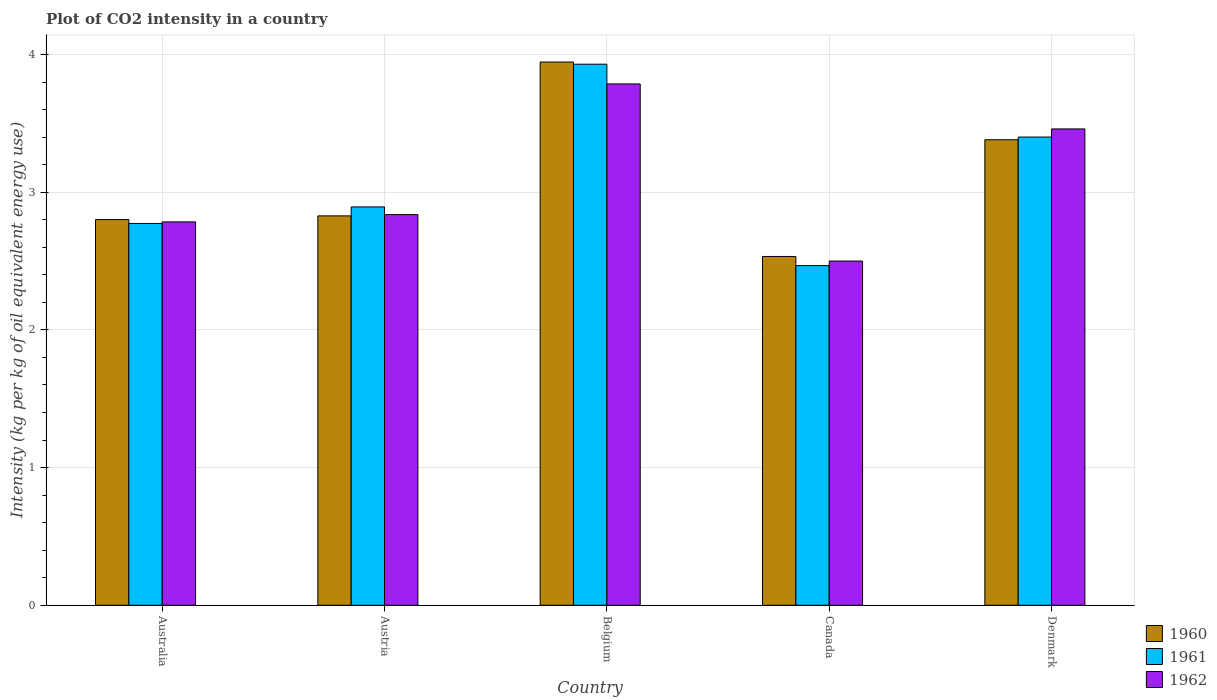Are the number of bars per tick equal to the number of legend labels?
Provide a succinct answer. Yes. Are the number of bars on each tick of the X-axis equal?
Offer a terse response. Yes. How many bars are there on the 2nd tick from the left?
Give a very brief answer. 3. What is the label of the 5th group of bars from the left?
Your answer should be very brief. Denmark. In how many cases, is the number of bars for a given country not equal to the number of legend labels?
Your response must be concise. 0. What is the CO2 intensity in in 1961 in Canada?
Make the answer very short. 2.47. Across all countries, what is the maximum CO2 intensity in in 1962?
Offer a terse response. 3.79. Across all countries, what is the minimum CO2 intensity in in 1960?
Provide a short and direct response. 2.53. In which country was the CO2 intensity in in 1960 minimum?
Your answer should be very brief. Canada. What is the total CO2 intensity in in 1961 in the graph?
Give a very brief answer. 15.47. What is the difference between the CO2 intensity in in 1960 in Austria and that in Canada?
Keep it short and to the point. 0.29. What is the difference between the CO2 intensity in in 1962 in Australia and the CO2 intensity in in 1960 in Belgium?
Offer a very short reply. -1.16. What is the average CO2 intensity in in 1962 per country?
Provide a succinct answer. 3.07. What is the difference between the CO2 intensity in of/in 1962 and CO2 intensity in of/in 1960 in Australia?
Your answer should be compact. -0.02. What is the ratio of the CO2 intensity in in 1960 in Belgium to that in Canada?
Your answer should be very brief. 1.56. Is the CO2 intensity in in 1961 in Canada less than that in Denmark?
Ensure brevity in your answer.  Yes. Is the difference between the CO2 intensity in in 1962 in Australia and Denmark greater than the difference between the CO2 intensity in in 1960 in Australia and Denmark?
Your answer should be compact. No. What is the difference between the highest and the second highest CO2 intensity in in 1961?
Your response must be concise. 0.51. What is the difference between the highest and the lowest CO2 intensity in in 1961?
Provide a short and direct response. 1.46. Is the sum of the CO2 intensity in in 1962 in Australia and Denmark greater than the maximum CO2 intensity in in 1961 across all countries?
Your answer should be compact. Yes. Are all the bars in the graph horizontal?
Provide a succinct answer. No. What is the difference between two consecutive major ticks on the Y-axis?
Keep it short and to the point. 1. Are the values on the major ticks of Y-axis written in scientific E-notation?
Your answer should be compact. No. Does the graph contain grids?
Make the answer very short. Yes. How are the legend labels stacked?
Keep it short and to the point. Vertical. What is the title of the graph?
Give a very brief answer. Plot of CO2 intensity in a country. Does "1996" appear as one of the legend labels in the graph?
Make the answer very short. No. What is the label or title of the X-axis?
Ensure brevity in your answer.  Country. What is the label or title of the Y-axis?
Ensure brevity in your answer.  Intensity (kg per kg of oil equivalent energy use). What is the Intensity (kg per kg of oil equivalent energy use) in 1960 in Australia?
Provide a succinct answer. 2.8. What is the Intensity (kg per kg of oil equivalent energy use) in 1961 in Australia?
Provide a succinct answer. 2.77. What is the Intensity (kg per kg of oil equivalent energy use) in 1962 in Australia?
Provide a succinct answer. 2.78. What is the Intensity (kg per kg of oil equivalent energy use) in 1960 in Austria?
Your answer should be compact. 2.83. What is the Intensity (kg per kg of oil equivalent energy use) in 1961 in Austria?
Provide a succinct answer. 2.89. What is the Intensity (kg per kg of oil equivalent energy use) in 1962 in Austria?
Make the answer very short. 2.84. What is the Intensity (kg per kg of oil equivalent energy use) in 1960 in Belgium?
Your answer should be compact. 3.95. What is the Intensity (kg per kg of oil equivalent energy use) in 1961 in Belgium?
Give a very brief answer. 3.93. What is the Intensity (kg per kg of oil equivalent energy use) of 1962 in Belgium?
Make the answer very short. 3.79. What is the Intensity (kg per kg of oil equivalent energy use) of 1960 in Canada?
Ensure brevity in your answer.  2.53. What is the Intensity (kg per kg of oil equivalent energy use) in 1961 in Canada?
Your answer should be very brief. 2.47. What is the Intensity (kg per kg of oil equivalent energy use) in 1962 in Canada?
Ensure brevity in your answer.  2.5. What is the Intensity (kg per kg of oil equivalent energy use) of 1960 in Denmark?
Your answer should be compact. 3.38. What is the Intensity (kg per kg of oil equivalent energy use) in 1961 in Denmark?
Keep it short and to the point. 3.4. What is the Intensity (kg per kg of oil equivalent energy use) of 1962 in Denmark?
Provide a succinct answer. 3.46. Across all countries, what is the maximum Intensity (kg per kg of oil equivalent energy use) of 1960?
Offer a terse response. 3.95. Across all countries, what is the maximum Intensity (kg per kg of oil equivalent energy use) in 1961?
Keep it short and to the point. 3.93. Across all countries, what is the maximum Intensity (kg per kg of oil equivalent energy use) of 1962?
Offer a very short reply. 3.79. Across all countries, what is the minimum Intensity (kg per kg of oil equivalent energy use) in 1960?
Make the answer very short. 2.53. Across all countries, what is the minimum Intensity (kg per kg of oil equivalent energy use) in 1961?
Your response must be concise. 2.47. Across all countries, what is the minimum Intensity (kg per kg of oil equivalent energy use) of 1962?
Make the answer very short. 2.5. What is the total Intensity (kg per kg of oil equivalent energy use) in 1960 in the graph?
Ensure brevity in your answer.  15.49. What is the total Intensity (kg per kg of oil equivalent energy use) in 1961 in the graph?
Keep it short and to the point. 15.47. What is the total Intensity (kg per kg of oil equivalent energy use) in 1962 in the graph?
Keep it short and to the point. 15.37. What is the difference between the Intensity (kg per kg of oil equivalent energy use) of 1960 in Australia and that in Austria?
Give a very brief answer. -0.03. What is the difference between the Intensity (kg per kg of oil equivalent energy use) of 1961 in Australia and that in Austria?
Keep it short and to the point. -0.12. What is the difference between the Intensity (kg per kg of oil equivalent energy use) in 1962 in Australia and that in Austria?
Give a very brief answer. -0.05. What is the difference between the Intensity (kg per kg of oil equivalent energy use) in 1960 in Australia and that in Belgium?
Provide a short and direct response. -1.14. What is the difference between the Intensity (kg per kg of oil equivalent energy use) in 1961 in Australia and that in Belgium?
Offer a terse response. -1.16. What is the difference between the Intensity (kg per kg of oil equivalent energy use) of 1962 in Australia and that in Belgium?
Your response must be concise. -1. What is the difference between the Intensity (kg per kg of oil equivalent energy use) of 1960 in Australia and that in Canada?
Offer a very short reply. 0.27. What is the difference between the Intensity (kg per kg of oil equivalent energy use) of 1961 in Australia and that in Canada?
Your answer should be very brief. 0.31. What is the difference between the Intensity (kg per kg of oil equivalent energy use) in 1962 in Australia and that in Canada?
Give a very brief answer. 0.28. What is the difference between the Intensity (kg per kg of oil equivalent energy use) of 1960 in Australia and that in Denmark?
Keep it short and to the point. -0.58. What is the difference between the Intensity (kg per kg of oil equivalent energy use) of 1961 in Australia and that in Denmark?
Provide a succinct answer. -0.63. What is the difference between the Intensity (kg per kg of oil equivalent energy use) of 1962 in Australia and that in Denmark?
Your answer should be very brief. -0.68. What is the difference between the Intensity (kg per kg of oil equivalent energy use) in 1960 in Austria and that in Belgium?
Give a very brief answer. -1.12. What is the difference between the Intensity (kg per kg of oil equivalent energy use) in 1961 in Austria and that in Belgium?
Provide a succinct answer. -1.04. What is the difference between the Intensity (kg per kg of oil equivalent energy use) in 1962 in Austria and that in Belgium?
Your answer should be very brief. -0.95. What is the difference between the Intensity (kg per kg of oil equivalent energy use) in 1960 in Austria and that in Canada?
Ensure brevity in your answer.  0.29. What is the difference between the Intensity (kg per kg of oil equivalent energy use) in 1961 in Austria and that in Canada?
Your answer should be very brief. 0.43. What is the difference between the Intensity (kg per kg of oil equivalent energy use) of 1962 in Austria and that in Canada?
Your answer should be very brief. 0.34. What is the difference between the Intensity (kg per kg of oil equivalent energy use) of 1960 in Austria and that in Denmark?
Ensure brevity in your answer.  -0.55. What is the difference between the Intensity (kg per kg of oil equivalent energy use) in 1961 in Austria and that in Denmark?
Give a very brief answer. -0.51. What is the difference between the Intensity (kg per kg of oil equivalent energy use) of 1962 in Austria and that in Denmark?
Your response must be concise. -0.62. What is the difference between the Intensity (kg per kg of oil equivalent energy use) of 1960 in Belgium and that in Canada?
Make the answer very short. 1.41. What is the difference between the Intensity (kg per kg of oil equivalent energy use) of 1961 in Belgium and that in Canada?
Give a very brief answer. 1.46. What is the difference between the Intensity (kg per kg of oil equivalent energy use) of 1962 in Belgium and that in Canada?
Your answer should be compact. 1.29. What is the difference between the Intensity (kg per kg of oil equivalent energy use) of 1960 in Belgium and that in Denmark?
Your response must be concise. 0.56. What is the difference between the Intensity (kg per kg of oil equivalent energy use) of 1961 in Belgium and that in Denmark?
Ensure brevity in your answer.  0.53. What is the difference between the Intensity (kg per kg of oil equivalent energy use) of 1962 in Belgium and that in Denmark?
Your answer should be very brief. 0.33. What is the difference between the Intensity (kg per kg of oil equivalent energy use) of 1960 in Canada and that in Denmark?
Offer a very short reply. -0.85. What is the difference between the Intensity (kg per kg of oil equivalent energy use) in 1961 in Canada and that in Denmark?
Make the answer very short. -0.93. What is the difference between the Intensity (kg per kg of oil equivalent energy use) of 1962 in Canada and that in Denmark?
Ensure brevity in your answer.  -0.96. What is the difference between the Intensity (kg per kg of oil equivalent energy use) in 1960 in Australia and the Intensity (kg per kg of oil equivalent energy use) in 1961 in Austria?
Make the answer very short. -0.09. What is the difference between the Intensity (kg per kg of oil equivalent energy use) of 1960 in Australia and the Intensity (kg per kg of oil equivalent energy use) of 1962 in Austria?
Ensure brevity in your answer.  -0.04. What is the difference between the Intensity (kg per kg of oil equivalent energy use) in 1961 in Australia and the Intensity (kg per kg of oil equivalent energy use) in 1962 in Austria?
Ensure brevity in your answer.  -0.06. What is the difference between the Intensity (kg per kg of oil equivalent energy use) of 1960 in Australia and the Intensity (kg per kg of oil equivalent energy use) of 1961 in Belgium?
Provide a succinct answer. -1.13. What is the difference between the Intensity (kg per kg of oil equivalent energy use) of 1960 in Australia and the Intensity (kg per kg of oil equivalent energy use) of 1962 in Belgium?
Provide a short and direct response. -0.99. What is the difference between the Intensity (kg per kg of oil equivalent energy use) of 1961 in Australia and the Intensity (kg per kg of oil equivalent energy use) of 1962 in Belgium?
Provide a short and direct response. -1.01. What is the difference between the Intensity (kg per kg of oil equivalent energy use) of 1960 in Australia and the Intensity (kg per kg of oil equivalent energy use) of 1961 in Canada?
Ensure brevity in your answer.  0.33. What is the difference between the Intensity (kg per kg of oil equivalent energy use) of 1960 in Australia and the Intensity (kg per kg of oil equivalent energy use) of 1962 in Canada?
Your answer should be very brief. 0.3. What is the difference between the Intensity (kg per kg of oil equivalent energy use) in 1961 in Australia and the Intensity (kg per kg of oil equivalent energy use) in 1962 in Canada?
Give a very brief answer. 0.27. What is the difference between the Intensity (kg per kg of oil equivalent energy use) of 1960 in Australia and the Intensity (kg per kg of oil equivalent energy use) of 1961 in Denmark?
Your answer should be very brief. -0.6. What is the difference between the Intensity (kg per kg of oil equivalent energy use) in 1960 in Australia and the Intensity (kg per kg of oil equivalent energy use) in 1962 in Denmark?
Make the answer very short. -0.66. What is the difference between the Intensity (kg per kg of oil equivalent energy use) in 1961 in Australia and the Intensity (kg per kg of oil equivalent energy use) in 1962 in Denmark?
Ensure brevity in your answer.  -0.69. What is the difference between the Intensity (kg per kg of oil equivalent energy use) of 1960 in Austria and the Intensity (kg per kg of oil equivalent energy use) of 1961 in Belgium?
Provide a short and direct response. -1.1. What is the difference between the Intensity (kg per kg of oil equivalent energy use) in 1960 in Austria and the Intensity (kg per kg of oil equivalent energy use) in 1962 in Belgium?
Your answer should be very brief. -0.96. What is the difference between the Intensity (kg per kg of oil equivalent energy use) of 1961 in Austria and the Intensity (kg per kg of oil equivalent energy use) of 1962 in Belgium?
Your answer should be very brief. -0.89. What is the difference between the Intensity (kg per kg of oil equivalent energy use) in 1960 in Austria and the Intensity (kg per kg of oil equivalent energy use) in 1961 in Canada?
Your answer should be very brief. 0.36. What is the difference between the Intensity (kg per kg of oil equivalent energy use) of 1960 in Austria and the Intensity (kg per kg of oil equivalent energy use) of 1962 in Canada?
Give a very brief answer. 0.33. What is the difference between the Intensity (kg per kg of oil equivalent energy use) of 1961 in Austria and the Intensity (kg per kg of oil equivalent energy use) of 1962 in Canada?
Keep it short and to the point. 0.39. What is the difference between the Intensity (kg per kg of oil equivalent energy use) of 1960 in Austria and the Intensity (kg per kg of oil equivalent energy use) of 1961 in Denmark?
Your answer should be very brief. -0.57. What is the difference between the Intensity (kg per kg of oil equivalent energy use) of 1960 in Austria and the Intensity (kg per kg of oil equivalent energy use) of 1962 in Denmark?
Give a very brief answer. -0.63. What is the difference between the Intensity (kg per kg of oil equivalent energy use) of 1961 in Austria and the Intensity (kg per kg of oil equivalent energy use) of 1962 in Denmark?
Your answer should be very brief. -0.57. What is the difference between the Intensity (kg per kg of oil equivalent energy use) in 1960 in Belgium and the Intensity (kg per kg of oil equivalent energy use) in 1961 in Canada?
Provide a succinct answer. 1.48. What is the difference between the Intensity (kg per kg of oil equivalent energy use) of 1960 in Belgium and the Intensity (kg per kg of oil equivalent energy use) of 1962 in Canada?
Provide a short and direct response. 1.45. What is the difference between the Intensity (kg per kg of oil equivalent energy use) in 1961 in Belgium and the Intensity (kg per kg of oil equivalent energy use) in 1962 in Canada?
Make the answer very short. 1.43. What is the difference between the Intensity (kg per kg of oil equivalent energy use) of 1960 in Belgium and the Intensity (kg per kg of oil equivalent energy use) of 1961 in Denmark?
Provide a short and direct response. 0.54. What is the difference between the Intensity (kg per kg of oil equivalent energy use) of 1960 in Belgium and the Intensity (kg per kg of oil equivalent energy use) of 1962 in Denmark?
Give a very brief answer. 0.49. What is the difference between the Intensity (kg per kg of oil equivalent energy use) of 1961 in Belgium and the Intensity (kg per kg of oil equivalent energy use) of 1962 in Denmark?
Ensure brevity in your answer.  0.47. What is the difference between the Intensity (kg per kg of oil equivalent energy use) of 1960 in Canada and the Intensity (kg per kg of oil equivalent energy use) of 1961 in Denmark?
Give a very brief answer. -0.87. What is the difference between the Intensity (kg per kg of oil equivalent energy use) in 1960 in Canada and the Intensity (kg per kg of oil equivalent energy use) in 1962 in Denmark?
Keep it short and to the point. -0.93. What is the difference between the Intensity (kg per kg of oil equivalent energy use) of 1961 in Canada and the Intensity (kg per kg of oil equivalent energy use) of 1962 in Denmark?
Offer a very short reply. -0.99. What is the average Intensity (kg per kg of oil equivalent energy use) in 1960 per country?
Offer a terse response. 3.1. What is the average Intensity (kg per kg of oil equivalent energy use) of 1961 per country?
Offer a very short reply. 3.09. What is the average Intensity (kg per kg of oil equivalent energy use) of 1962 per country?
Offer a terse response. 3.07. What is the difference between the Intensity (kg per kg of oil equivalent energy use) in 1960 and Intensity (kg per kg of oil equivalent energy use) in 1961 in Australia?
Your answer should be compact. 0.03. What is the difference between the Intensity (kg per kg of oil equivalent energy use) of 1960 and Intensity (kg per kg of oil equivalent energy use) of 1962 in Australia?
Keep it short and to the point. 0.02. What is the difference between the Intensity (kg per kg of oil equivalent energy use) of 1961 and Intensity (kg per kg of oil equivalent energy use) of 1962 in Australia?
Provide a succinct answer. -0.01. What is the difference between the Intensity (kg per kg of oil equivalent energy use) in 1960 and Intensity (kg per kg of oil equivalent energy use) in 1961 in Austria?
Provide a succinct answer. -0.07. What is the difference between the Intensity (kg per kg of oil equivalent energy use) of 1960 and Intensity (kg per kg of oil equivalent energy use) of 1962 in Austria?
Offer a terse response. -0.01. What is the difference between the Intensity (kg per kg of oil equivalent energy use) of 1961 and Intensity (kg per kg of oil equivalent energy use) of 1962 in Austria?
Keep it short and to the point. 0.06. What is the difference between the Intensity (kg per kg of oil equivalent energy use) in 1960 and Intensity (kg per kg of oil equivalent energy use) in 1961 in Belgium?
Give a very brief answer. 0.02. What is the difference between the Intensity (kg per kg of oil equivalent energy use) of 1960 and Intensity (kg per kg of oil equivalent energy use) of 1962 in Belgium?
Offer a terse response. 0.16. What is the difference between the Intensity (kg per kg of oil equivalent energy use) in 1961 and Intensity (kg per kg of oil equivalent energy use) in 1962 in Belgium?
Keep it short and to the point. 0.14. What is the difference between the Intensity (kg per kg of oil equivalent energy use) of 1960 and Intensity (kg per kg of oil equivalent energy use) of 1961 in Canada?
Your answer should be compact. 0.07. What is the difference between the Intensity (kg per kg of oil equivalent energy use) in 1960 and Intensity (kg per kg of oil equivalent energy use) in 1962 in Canada?
Provide a short and direct response. 0.03. What is the difference between the Intensity (kg per kg of oil equivalent energy use) in 1961 and Intensity (kg per kg of oil equivalent energy use) in 1962 in Canada?
Make the answer very short. -0.03. What is the difference between the Intensity (kg per kg of oil equivalent energy use) in 1960 and Intensity (kg per kg of oil equivalent energy use) in 1961 in Denmark?
Give a very brief answer. -0.02. What is the difference between the Intensity (kg per kg of oil equivalent energy use) in 1960 and Intensity (kg per kg of oil equivalent energy use) in 1962 in Denmark?
Offer a very short reply. -0.08. What is the difference between the Intensity (kg per kg of oil equivalent energy use) in 1961 and Intensity (kg per kg of oil equivalent energy use) in 1962 in Denmark?
Your response must be concise. -0.06. What is the ratio of the Intensity (kg per kg of oil equivalent energy use) in 1960 in Australia to that in Austria?
Your answer should be very brief. 0.99. What is the ratio of the Intensity (kg per kg of oil equivalent energy use) of 1961 in Australia to that in Austria?
Offer a terse response. 0.96. What is the ratio of the Intensity (kg per kg of oil equivalent energy use) of 1962 in Australia to that in Austria?
Offer a terse response. 0.98. What is the ratio of the Intensity (kg per kg of oil equivalent energy use) of 1960 in Australia to that in Belgium?
Ensure brevity in your answer.  0.71. What is the ratio of the Intensity (kg per kg of oil equivalent energy use) in 1961 in Australia to that in Belgium?
Offer a terse response. 0.71. What is the ratio of the Intensity (kg per kg of oil equivalent energy use) of 1962 in Australia to that in Belgium?
Ensure brevity in your answer.  0.74. What is the ratio of the Intensity (kg per kg of oil equivalent energy use) in 1960 in Australia to that in Canada?
Provide a succinct answer. 1.11. What is the ratio of the Intensity (kg per kg of oil equivalent energy use) in 1961 in Australia to that in Canada?
Offer a very short reply. 1.12. What is the ratio of the Intensity (kg per kg of oil equivalent energy use) in 1962 in Australia to that in Canada?
Make the answer very short. 1.11. What is the ratio of the Intensity (kg per kg of oil equivalent energy use) in 1960 in Australia to that in Denmark?
Offer a very short reply. 0.83. What is the ratio of the Intensity (kg per kg of oil equivalent energy use) of 1961 in Australia to that in Denmark?
Provide a short and direct response. 0.82. What is the ratio of the Intensity (kg per kg of oil equivalent energy use) in 1962 in Australia to that in Denmark?
Offer a very short reply. 0.8. What is the ratio of the Intensity (kg per kg of oil equivalent energy use) in 1960 in Austria to that in Belgium?
Your response must be concise. 0.72. What is the ratio of the Intensity (kg per kg of oil equivalent energy use) in 1961 in Austria to that in Belgium?
Offer a terse response. 0.74. What is the ratio of the Intensity (kg per kg of oil equivalent energy use) of 1962 in Austria to that in Belgium?
Offer a terse response. 0.75. What is the ratio of the Intensity (kg per kg of oil equivalent energy use) of 1960 in Austria to that in Canada?
Give a very brief answer. 1.12. What is the ratio of the Intensity (kg per kg of oil equivalent energy use) in 1961 in Austria to that in Canada?
Provide a short and direct response. 1.17. What is the ratio of the Intensity (kg per kg of oil equivalent energy use) of 1962 in Austria to that in Canada?
Your response must be concise. 1.13. What is the ratio of the Intensity (kg per kg of oil equivalent energy use) in 1960 in Austria to that in Denmark?
Offer a very short reply. 0.84. What is the ratio of the Intensity (kg per kg of oil equivalent energy use) of 1961 in Austria to that in Denmark?
Your answer should be compact. 0.85. What is the ratio of the Intensity (kg per kg of oil equivalent energy use) of 1962 in Austria to that in Denmark?
Ensure brevity in your answer.  0.82. What is the ratio of the Intensity (kg per kg of oil equivalent energy use) in 1960 in Belgium to that in Canada?
Give a very brief answer. 1.56. What is the ratio of the Intensity (kg per kg of oil equivalent energy use) of 1961 in Belgium to that in Canada?
Offer a terse response. 1.59. What is the ratio of the Intensity (kg per kg of oil equivalent energy use) in 1962 in Belgium to that in Canada?
Offer a terse response. 1.51. What is the ratio of the Intensity (kg per kg of oil equivalent energy use) in 1960 in Belgium to that in Denmark?
Keep it short and to the point. 1.17. What is the ratio of the Intensity (kg per kg of oil equivalent energy use) of 1961 in Belgium to that in Denmark?
Your answer should be compact. 1.16. What is the ratio of the Intensity (kg per kg of oil equivalent energy use) of 1962 in Belgium to that in Denmark?
Keep it short and to the point. 1.09. What is the ratio of the Intensity (kg per kg of oil equivalent energy use) of 1960 in Canada to that in Denmark?
Provide a short and direct response. 0.75. What is the ratio of the Intensity (kg per kg of oil equivalent energy use) of 1961 in Canada to that in Denmark?
Ensure brevity in your answer.  0.73. What is the ratio of the Intensity (kg per kg of oil equivalent energy use) in 1962 in Canada to that in Denmark?
Your answer should be very brief. 0.72. What is the difference between the highest and the second highest Intensity (kg per kg of oil equivalent energy use) in 1960?
Your response must be concise. 0.56. What is the difference between the highest and the second highest Intensity (kg per kg of oil equivalent energy use) in 1961?
Your answer should be compact. 0.53. What is the difference between the highest and the second highest Intensity (kg per kg of oil equivalent energy use) of 1962?
Ensure brevity in your answer.  0.33. What is the difference between the highest and the lowest Intensity (kg per kg of oil equivalent energy use) of 1960?
Your answer should be compact. 1.41. What is the difference between the highest and the lowest Intensity (kg per kg of oil equivalent energy use) of 1961?
Provide a succinct answer. 1.46. What is the difference between the highest and the lowest Intensity (kg per kg of oil equivalent energy use) in 1962?
Provide a short and direct response. 1.29. 